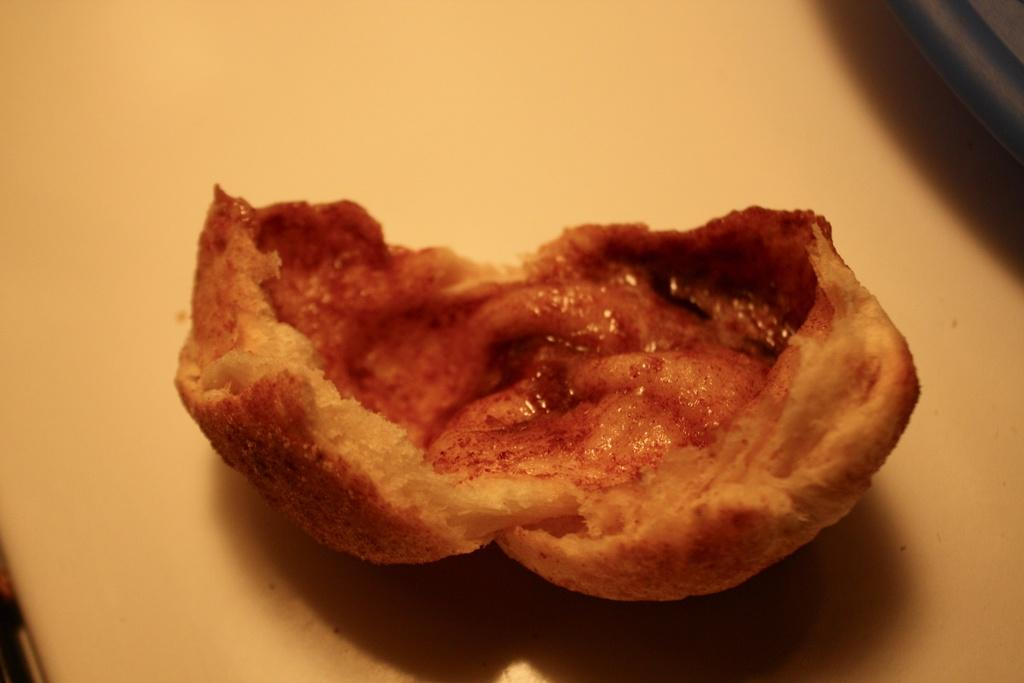What is the main subject of the image? There is a food item in the image. Where is the food item located? The food item is placed on a table. How is the food item positioned on the table? The food item is in the center of the image. How many times does the food item turn in the image? The food item does not turn in the image; it is stationary on the table. What type of screw is used to secure the food item to the table? There is no screw present in the image, as the food item is simply placed on the table. 